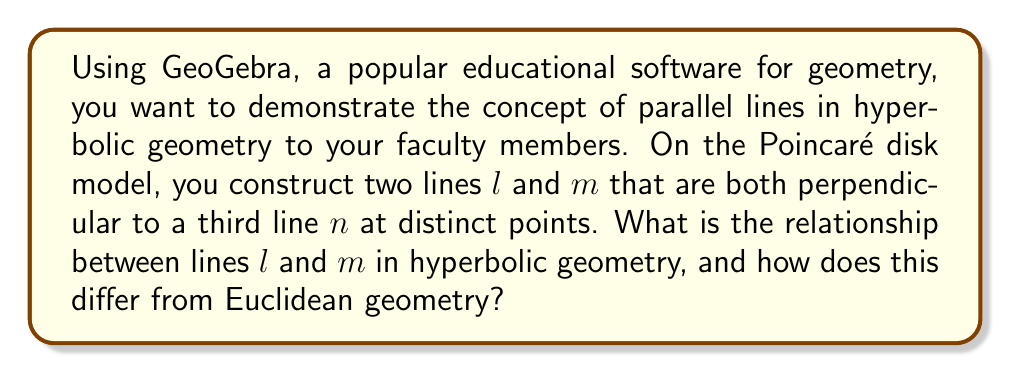Help me with this question. To understand this problem, let's follow these steps:

1) In Euclidean geometry, two lines perpendicular to a third line are parallel to each other. This is known as the parallel postulate.

2) However, in hyperbolic geometry, this is not the case. Let's visualize this using the Poincaré disk model:

   [asy]
   import geometry;
   
   unitcircle();
   
   pair A = (0.5,0);
   pair B = (-0.5,0);
   pair C = (0.866,0.5);
   pair D = (-0.866,-0.5);
   
   draw(Arc(C,A,D));
   draw(Arc(D,B,C));
   draw((-1,0)--(1,0));
   
   dot("A",A,E);
   dot("B",B,W);
   
   label("$l$", (0.7,0.7), N);
   label("$m$", (-0.7,-0.7), S);
   label("$n$", (1,0), E);
   [/asy]

3) In this model, straight lines in hyperbolic geometry are represented by arcs of circles that are perpendicular to the boundary of the disk.

4) Lines $l$ and $m$ are both perpendicular to line $n$, which is represented by the diameter of the disk.

5) In Euclidean geometry, $l$ and $m$ would be parallel. However, in hyperbolic geometry, we can see that $l$ and $m$ diverge from each other as they extend away from line $n$.

6) This divergence is a key property of hyperbolic geometry. Lines that are perpendicular to a common line are called "ultraparallel" or "hyperparallel".

7) Ultraparallel lines in hyperbolic geometry have a unique property: they have a common perpendicular line that is the shortest distance between them.

8) This demonstrates that in hyperbolic geometry, there are infinitely many lines through a point that do not intersect a given line, contradicting the parallel postulate of Euclidean geometry.
Answer: Lines $l$ and $m$ are ultraparallel in hyperbolic geometry, diverging from each other, unlike in Euclidean geometry where they would be parallel. 